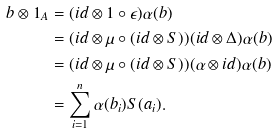Convert formula to latex. <formula><loc_0><loc_0><loc_500><loc_500>b \otimes 1 _ { A } & = ( i d \otimes 1 \circ \epsilon ) \alpha ( b ) \\ & = ( i d \otimes \mu \circ ( i d \otimes S ) ) ( i d \otimes \Delta ) \alpha ( b ) \\ & = ( i d \otimes \mu \circ ( i d \otimes S ) ) ( \alpha \otimes i d ) \alpha ( b ) \\ & = \sum _ { i = 1 } ^ { n } \alpha ( b _ { i } ) S ( a _ { i } ) .</formula> 